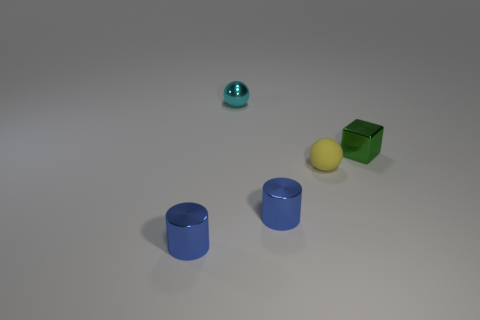What number of things are tiny metal spheres or tiny metallic things that are to the right of the cyan sphere?
Give a very brief answer. 3. What is the color of the small cube that is made of the same material as the cyan sphere?
Provide a succinct answer. Green. How many other small green things have the same material as the tiny green object?
Your answer should be compact. 0. What number of tiny cyan metal spheres are there?
Your response must be concise. 1. There is a cylinder that is right of the small cyan metallic sphere; is its color the same as the small cylinder that is left of the tiny cyan metallic thing?
Give a very brief answer. Yes. How many tiny things are in front of the tiny block?
Offer a very short reply. 3. Are there any other objects that have the same shape as the cyan object?
Your response must be concise. Yes. Are the tiny thing that is right of the tiny yellow sphere and the small ball in front of the green shiny cube made of the same material?
Your response must be concise. No. What is the material of the cyan sphere that is the same size as the green shiny object?
Your answer should be compact. Metal. Are there any other purple metal blocks of the same size as the shiny block?
Make the answer very short. No. 